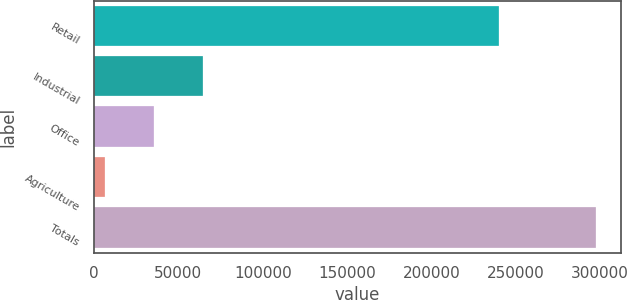<chart> <loc_0><loc_0><loc_500><loc_500><bar_chart><fcel>Retail<fcel>Industrial<fcel>Office<fcel>Agriculture<fcel>Totals<nl><fcel>240006<fcel>64754.2<fcel>35662.6<fcel>6571<fcel>297487<nl></chart> 